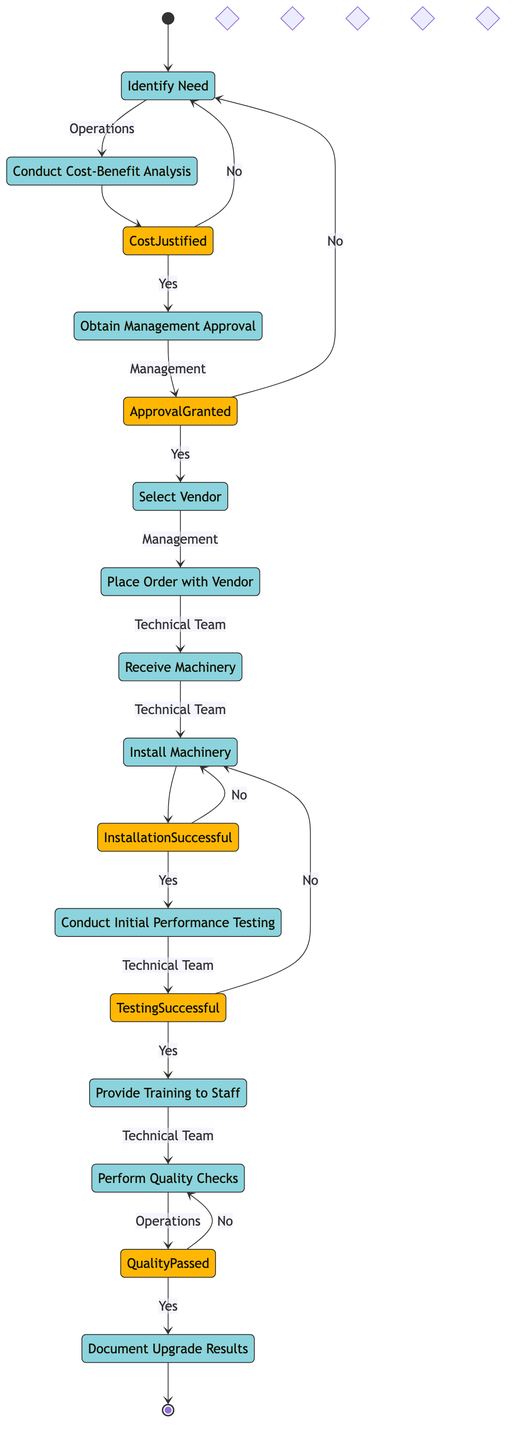What is the starting activity in this process? The starting activity is indicated at the beginning of the diagram and is labeled "Identify Need for Machinery Upgrade."
Answer: Identify Need for Machinery Upgrade How many decisions are present in the diagram? The diagram has five decision points, which can be counted as specific points branching the flow based on conditions like cost justification and testing success.
Answer: 5 What activity follows "Obtain Management Approval"? According to the flow, after obtaining management approval, the next activity is selecting a vendor.
Answer: Select Vendor What is the final activity in the process? The final activity is shown at the end of the diagram and is labeled "Document Upgrade Results."
Answer: Document Upgrade Results Which swimlane contains the activity "Receive Machinery"? The activity "Receive Machinery" is located in the "Technical Team" swimlane, which includes activities related to machinery handling.
Answer: Technical Team If the cost is not justified, what activity does the diagram return to? If the cost is not justified, the diagram returns to the activity labeled "Identify Need for Machinery Upgrade," looping back to reassess the need.
Answer: Identify Need for Machinery Upgrade What happens if the installation is successful? If installation is successful, the flow continues to "Conduct Initial Performance Testing." This indicates a progression following the success of the installation.
Answer: Conduct Initial Performance Testing How many activities are in the "Operations" swimlane? The "Operations" swimlane contains three activities, which are listed explicitly within that lane of the diagram.
Answer: 3 What decision must occur after conducting the initial performance testing? After conducting initial performance testing, the diagram presents the decision "Testing Successful?" which branches the flow based on whether the testing meets success criteria.
Answer: Testing Successful? 